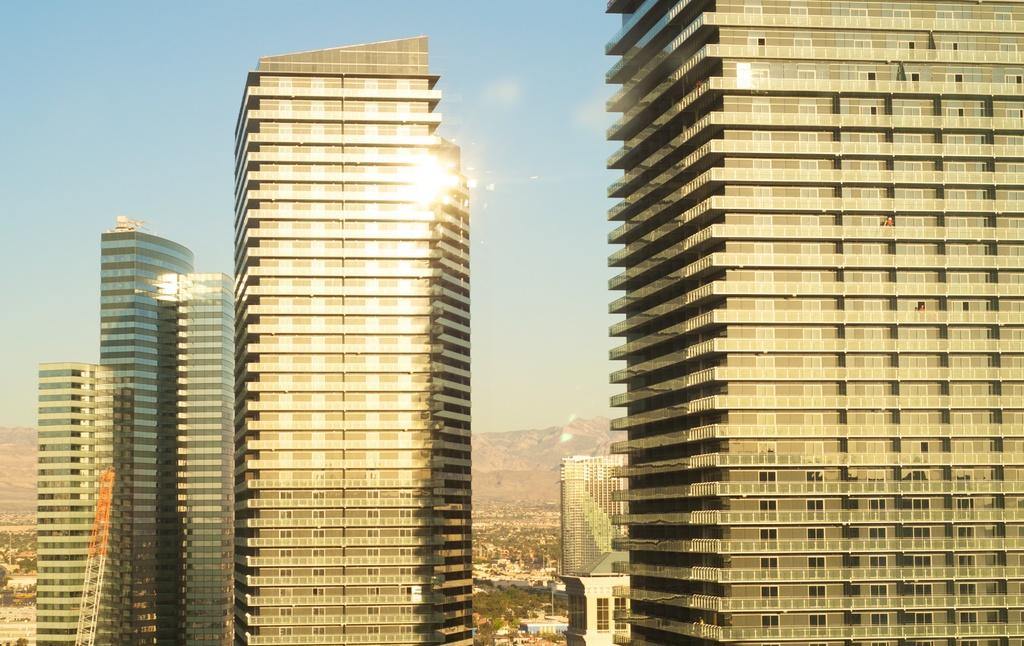What type of structures are present in the image? There are tower buildings in the image. What is located at the bottom of the buildings? There are trees at the bottom of the buildings. What type of natural feature can be seen in the image? There are hills visible in the image. What is visible in the top part of the image? The sky is visible in the image. What type of mark can be seen on the trees in the image? There is no mark visible on the trees in the image. What news is being reported by the plough in the image? There is no plough present in the image, and therefore no news can be reported by it. 